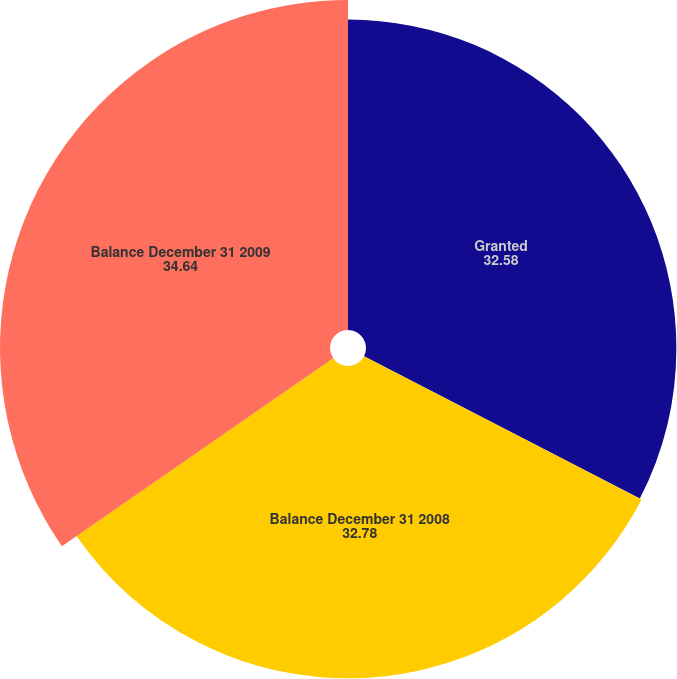Convert chart. <chart><loc_0><loc_0><loc_500><loc_500><pie_chart><fcel>Granted<fcel>Balance December 31 2008<fcel>Balance December 31 2009<nl><fcel>32.58%<fcel>32.78%<fcel>34.64%<nl></chart> 